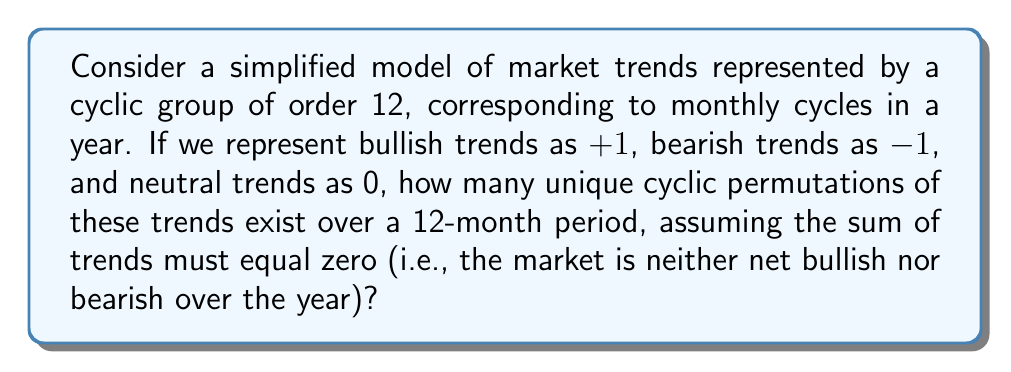Give your solution to this math problem. To solve this problem, we'll use concepts from ring theory and combinatorics:

1) First, we need to understand the constraints:
   - We have a cyclic group of order 12 (representing 12 months)
   - Each element can be +1, -1, or 0
   - The sum of all elements must be 0

2) Let's define variables:
   Let $a$ be the number of +1's, $b$ be the number of -1's, and $c$ be the number of 0's.

3) We can form two equations:
   $a + b + c = 12$ (total number of months)
   $a - b = 0$ (sum of trends equals zero)

4) From the second equation, we know $a = b$. Let's call this number $k$.
   So, $2k + c = 12$

5) Solving for $c$:
   $c = 12 - 2k$

6) Now, we need to find how many ways we can arrange these elements cyclically.
   This is equivalent to finding the number of necklaces with $k$ white beads, $k$ black beads, and $12-2k$ red beads.

7) We can use Burnside's lemma for this. The formula for the number of necklaces is:

   $$ N = \frac{1}{12} \sum_{d|12} \phi(d) 3^{12/d} $$

   Where $\phi(d)$ is Euler's totient function.

8) Calculating this:
   For $d = 1$: $\phi(1) \cdot 3^{12} = 1 \cdot 531441$
   For $d = 2$: $\phi(2) \cdot 3^6 = 1 \cdot 729$
   For $d = 3$: $\phi(3) \cdot 3^4 = 2 \cdot 81 = 162$
   For $d = 4$: $\phi(4) \cdot 3^3 = 2 \cdot 27 = 54$
   For $d = 6$: $\phi(6) \cdot 3^2 = 2 \cdot 9 = 18$
   For $d = 12$: $\phi(12) \cdot 3^1 = 4 \cdot 3 = 12$

9) Sum these up and divide by 12:
   $N = \frac{1}{12}(531441 + 729 + 162 + 54 + 18 + 12) = 44368$

Therefore, there are 44,368 unique cyclic permutations of market trends over a 12-month period under these constraints.
Answer: 44,368 unique cyclic permutations 